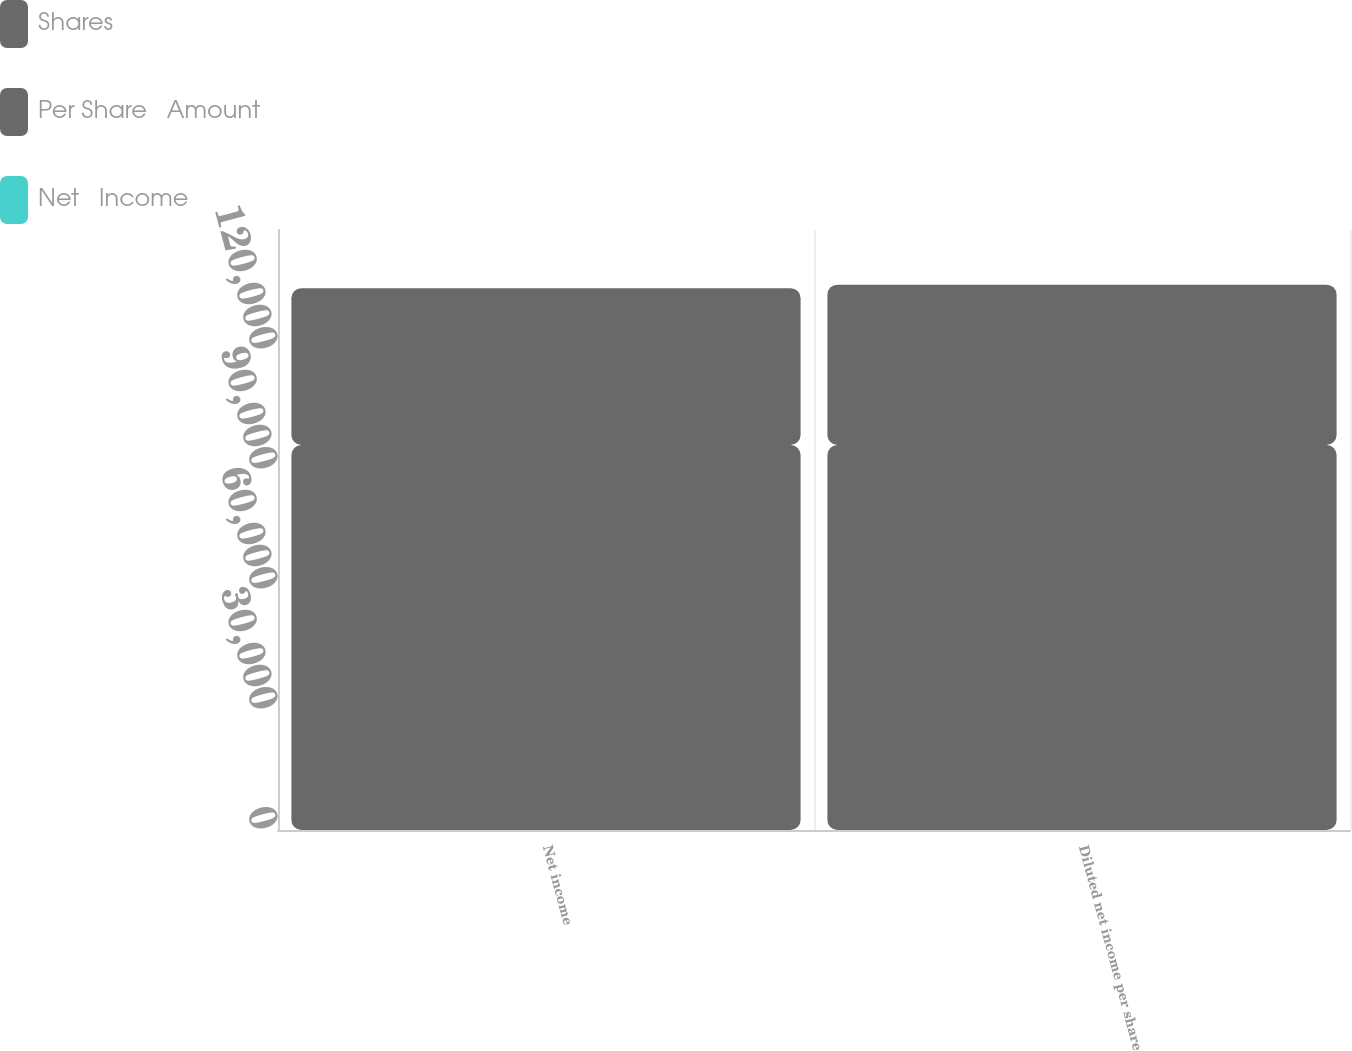<chart> <loc_0><loc_0><loc_500><loc_500><stacked_bar_chart><ecel><fcel>Net income<fcel>Diluted net income per share<nl><fcel>Shares<fcel>96241<fcel>96241<nl><fcel>Per Share   Amount<fcel>39220<fcel>40100<nl><fcel>Net   Income<fcel>2.45<fcel>2.4<nl></chart> 